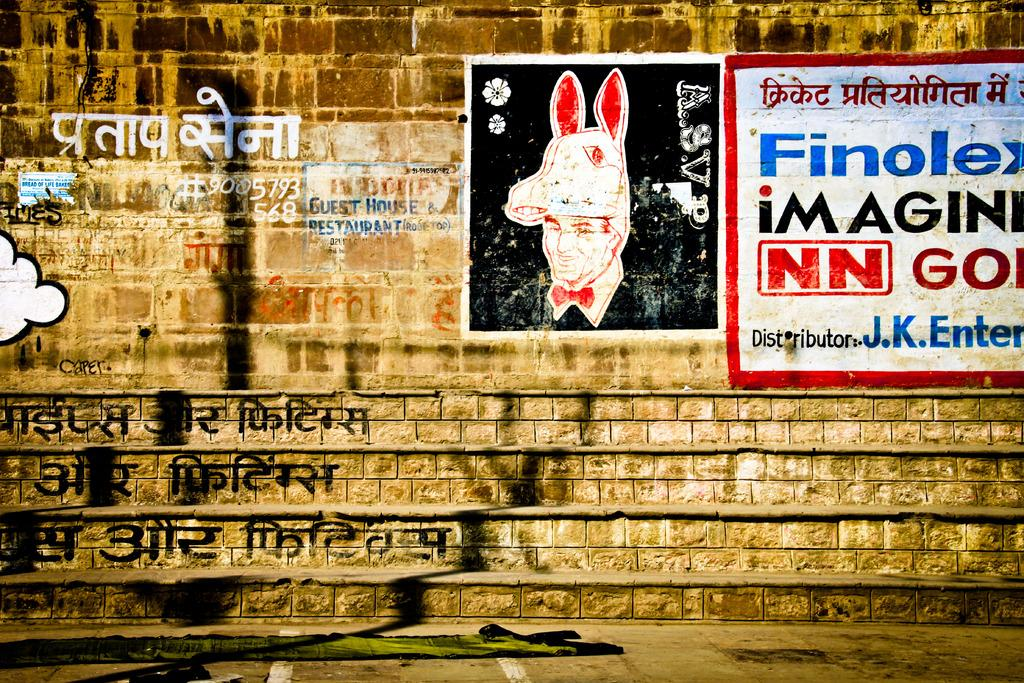What is on the wall in the image? There are paintings on the wall in the image. What type of flag is being waved by the students in the class? There is no class or flag present in the image; it only features paintings on the wall. 